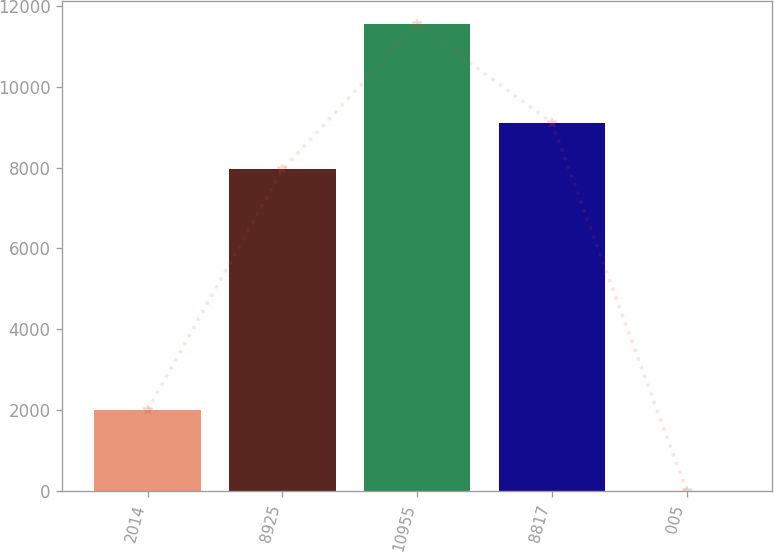Convert chart to OTSL. <chart><loc_0><loc_0><loc_500><loc_500><bar_chart><fcel>2014<fcel>8925<fcel>10955<fcel>8817<fcel>005<nl><fcel>2013<fcel>7953<fcel>11538<fcel>9106.43<fcel>3.68<nl></chart> 